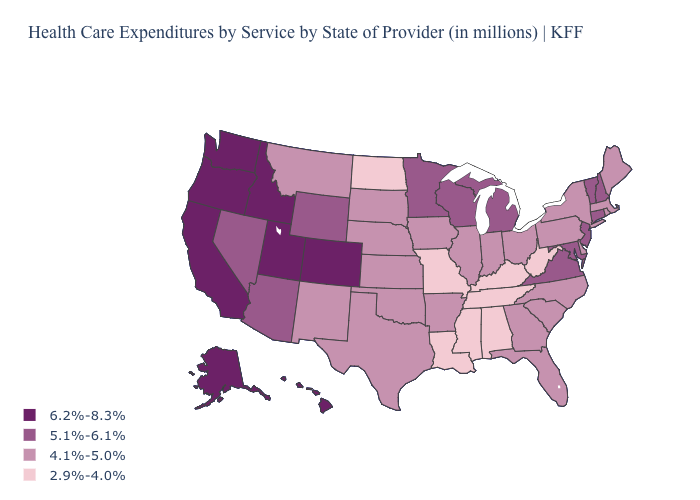Among the states that border North Carolina , does Virginia have the lowest value?
Short answer required. No. What is the value of Ohio?
Write a very short answer. 4.1%-5.0%. Does Washington have the lowest value in the West?
Give a very brief answer. No. Which states hav the highest value in the South?
Give a very brief answer. Maryland, Virginia. What is the lowest value in the MidWest?
Concise answer only. 2.9%-4.0%. Name the states that have a value in the range 5.1%-6.1%?
Keep it brief. Arizona, Connecticut, Maryland, Michigan, Minnesota, Nevada, New Hampshire, New Jersey, Vermont, Virginia, Wisconsin, Wyoming. Which states have the lowest value in the USA?
Be succinct. Alabama, Kentucky, Louisiana, Mississippi, Missouri, North Dakota, Tennessee, West Virginia. What is the value of Vermont?
Concise answer only. 5.1%-6.1%. Among the states that border Ohio , which have the highest value?
Keep it brief. Michigan. Name the states that have a value in the range 5.1%-6.1%?
Answer briefly. Arizona, Connecticut, Maryland, Michigan, Minnesota, Nevada, New Hampshire, New Jersey, Vermont, Virginia, Wisconsin, Wyoming. Name the states that have a value in the range 4.1%-5.0%?
Answer briefly. Arkansas, Delaware, Florida, Georgia, Illinois, Indiana, Iowa, Kansas, Maine, Massachusetts, Montana, Nebraska, New Mexico, New York, North Carolina, Ohio, Oklahoma, Pennsylvania, Rhode Island, South Carolina, South Dakota, Texas. Does the first symbol in the legend represent the smallest category?
Give a very brief answer. No. What is the value of Colorado?
Keep it brief. 6.2%-8.3%. Which states have the lowest value in the West?
Write a very short answer. Montana, New Mexico. Which states hav the highest value in the South?
Give a very brief answer. Maryland, Virginia. 